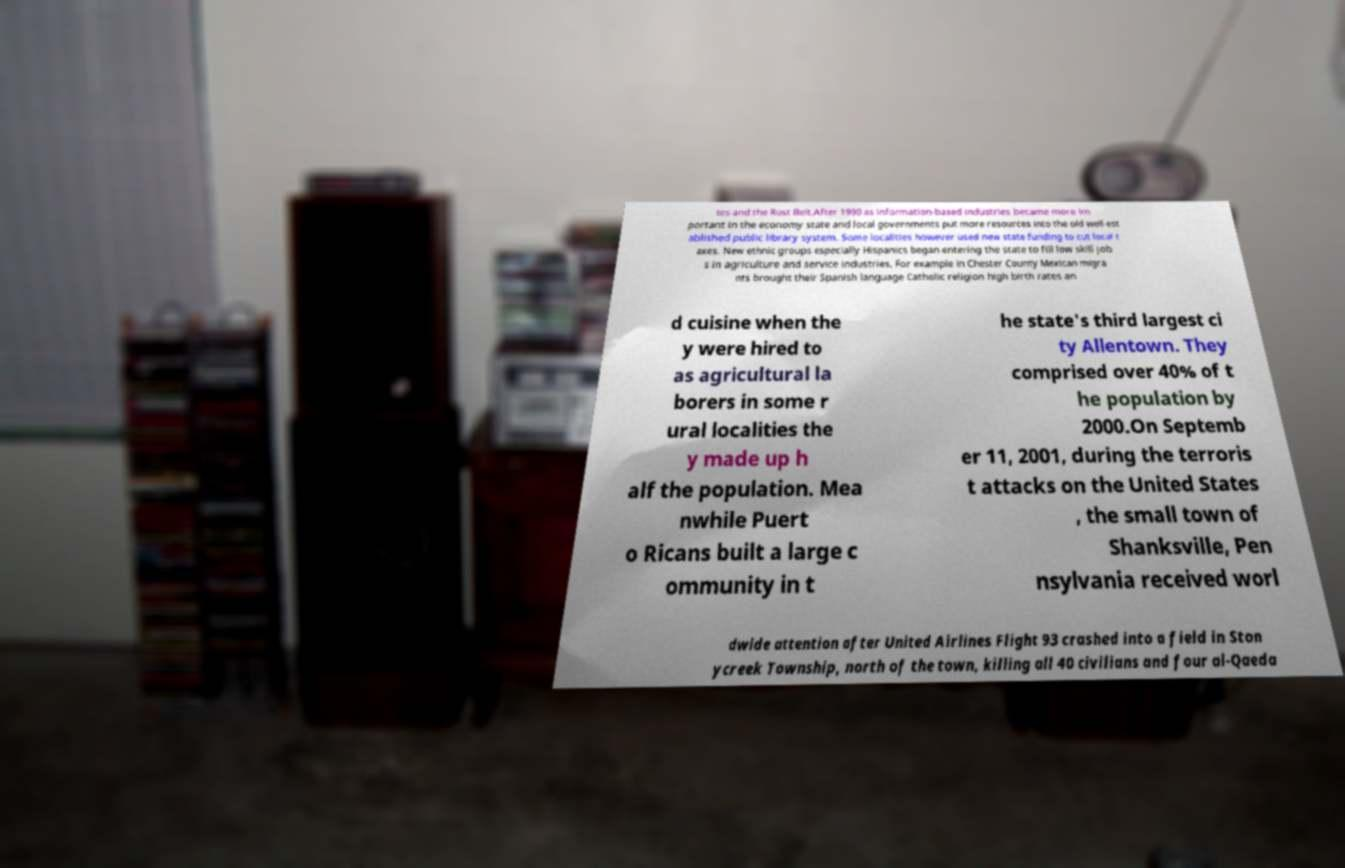Please read and relay the text visible in this image. What does it say? tes and the Rust Belt.After 1990 as information-based industries became more im portant in the economy state and local governments put more resources into the old well-est ablished public library system. Some localities however used new state funding to cut local t axes. New ethnic groups especially Hispanics began entering the state to fill low skill job s in agriculture and service industries. For example in Chester County Mexican migra nts brought their Spanish language Catholic religion high birth rates an d cuisine when the y were hired to as agricultural la borers in some r ural localities the y made up h alf the population. Mea nwhile Puert o Ricans built a large c ommunity in t he state's third largest ci ty Allentown. They comprised over 40% of t he population by 2000.On Septemb er 11, 2001, during the terroris t attacks on the United States , the small town of Shanksville, Pen nsylvania received worl dwide attention after United Airlines Flight 93 crashed into a field in Ston ycreek Township, north of the town, killing all 40 civilians and four al-Qaeda 